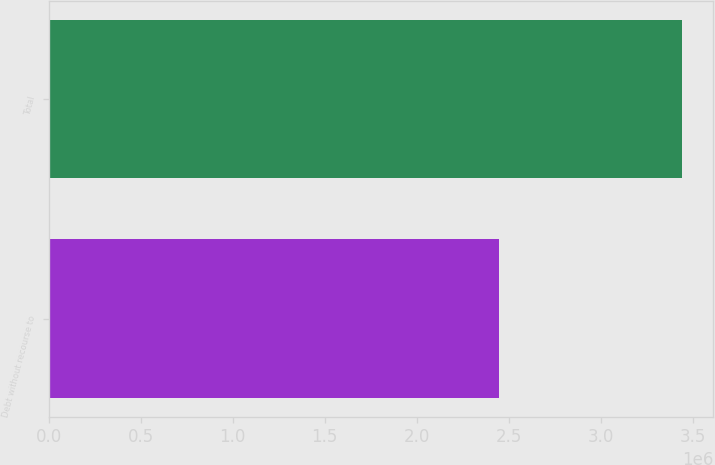<chart> <loc_0><loc_0><loc_500><loc_500><bar_chart><fcel>Debt without recourse to<fcel>Total<nl><fcel>2.45005e+06<fcel>3.44008e+06<nl></chart> 